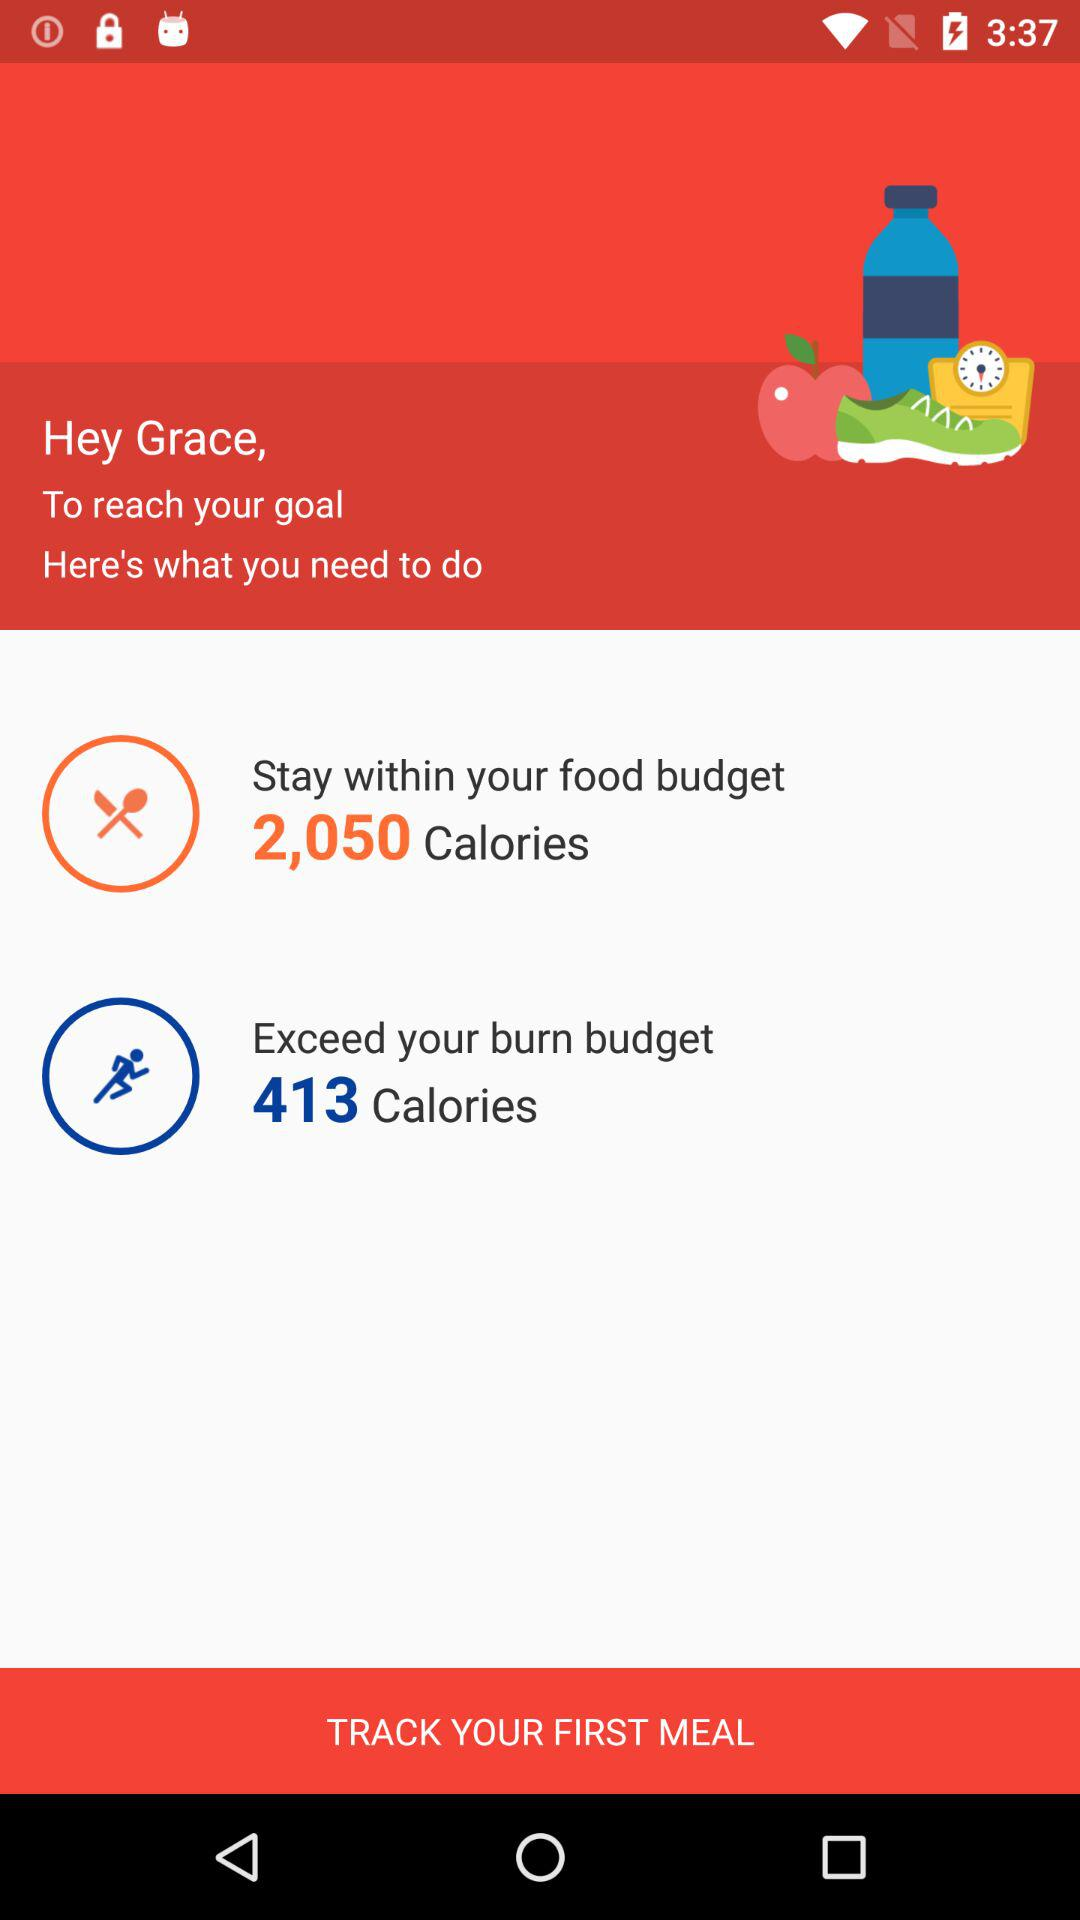How many calories are there for a burn budget? There are 413 calories. 